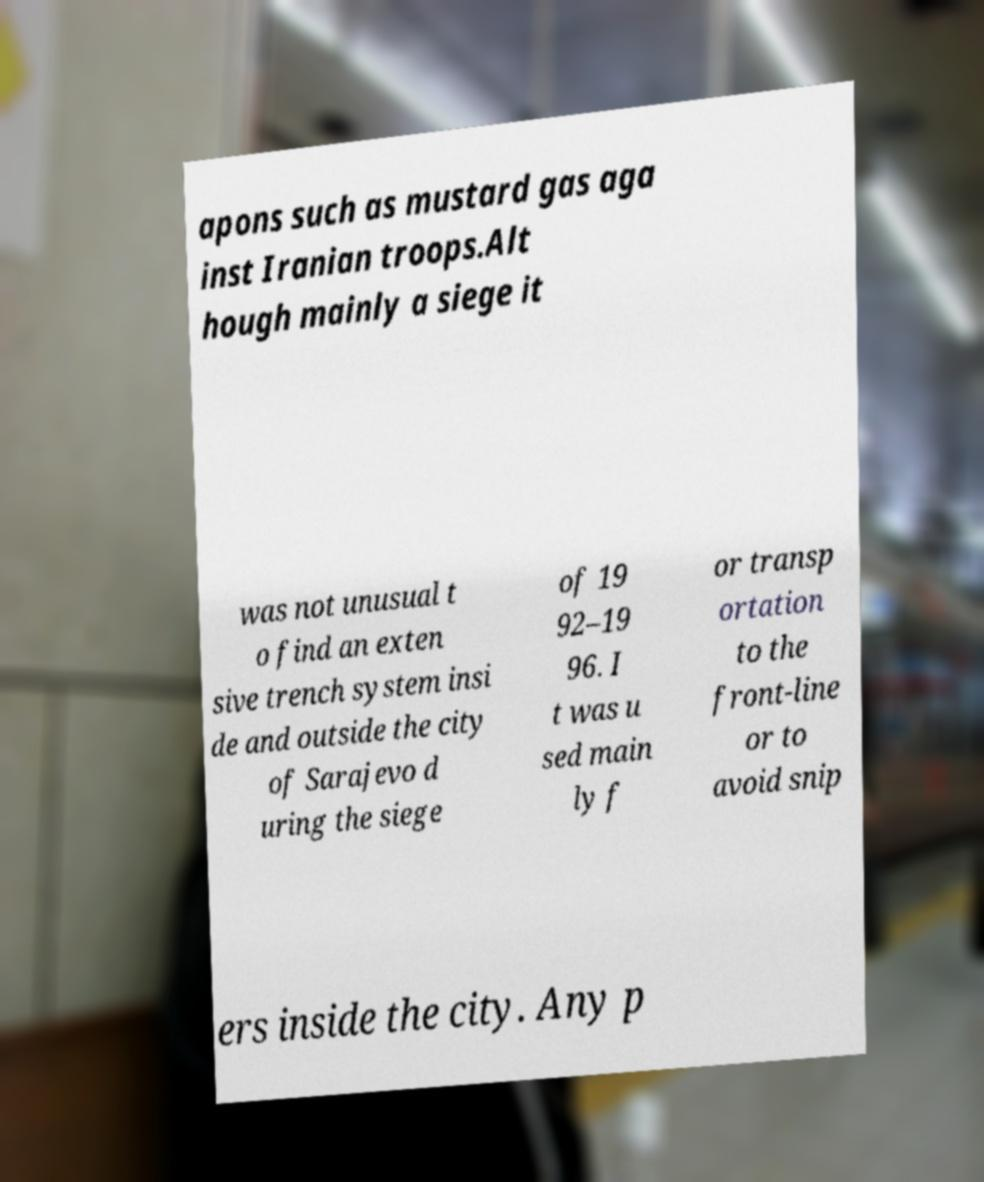There's text embedded in this image that I need extracted. Can you transcribe it verbatim? apons such as mustard gas aga inst Iranian troops.Alt hough mainly a siege it was not unusual t o find an exten sive trench system insi de and outside the city of Sarajevo d uring the siege of 19 92–19 96. I t was u sed main ly f or transp ortation to the front-line or to avoid snip ers inside the city. Any p 